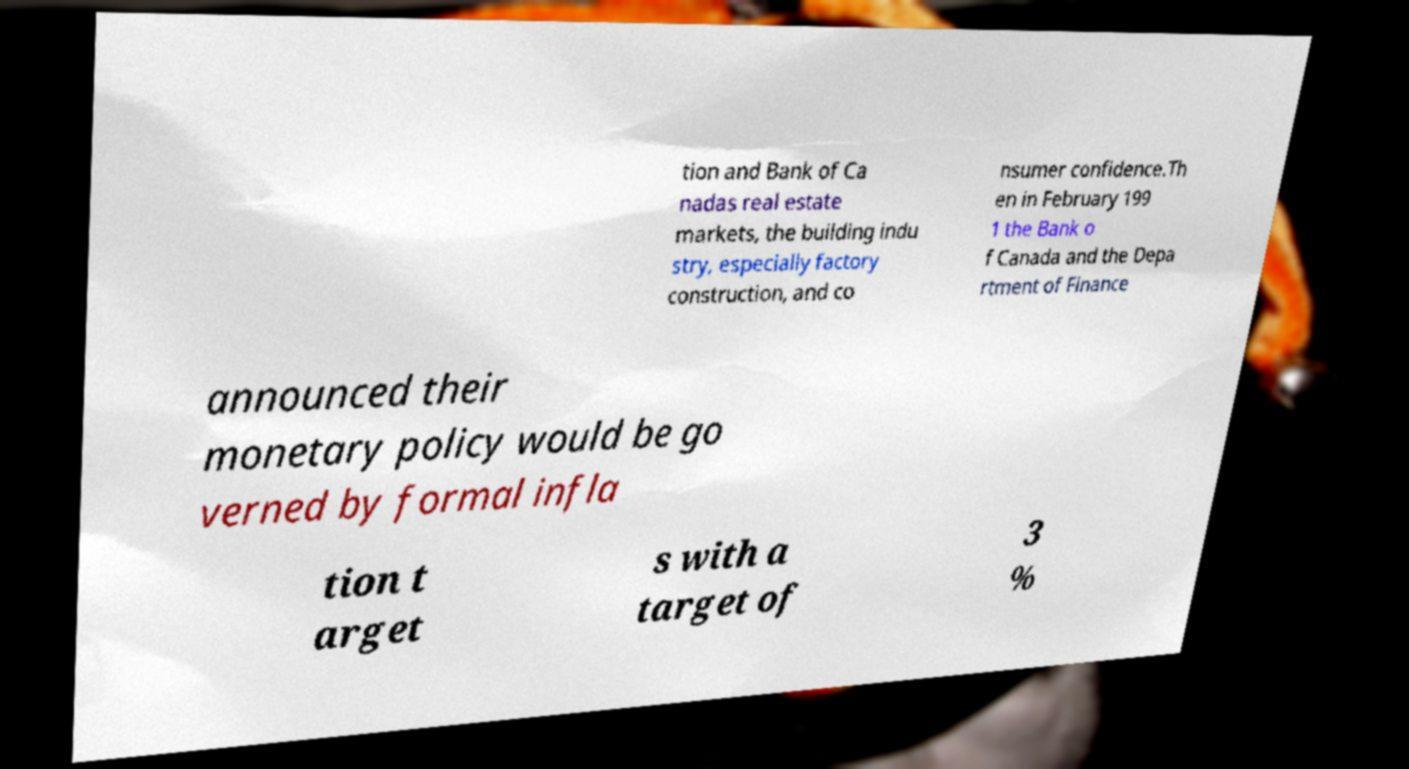Can you accurately transcribe the text from the provided image for me? tion and Bank of Ca nadas real estate markets, the building indu stry, especially factory construction, and co nsumer confidence.Th en in February 199 1 the Bank o f Canada and the Depa rtment of Finance announced their monetary policy would be go verned by formal infla tion t arget s with a target of 3 % 